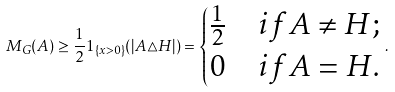<formula> <loc_0><loc_0><loc_500><loc_500>M _ { G } ( A ) \geq \frac { 1 } { 2 } 1 _ { \{ x > 0 \} } ( | A \triangle H | ) = \begin{cases} \frac { 1 } { 2 } & i f A \neq H ; \\ 0 & i f A = H . \end{cases} .</formula> 